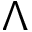<formula> <loc_0><loc_0><loc_500><loc_500>\Lambda</formula> 